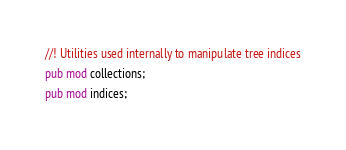Convert code to text. <code><loc_0><loc_0><loc_500><loc_500><_Rust_>//! Utilities used internally to manipulate tree indices
pub mod collections;
pub mod indices;
</code> 